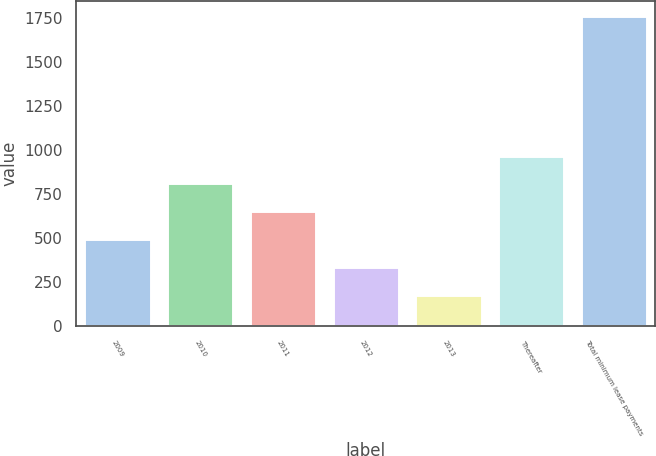Convert chart. <chart><loc_0><loc_0><loc_500><loc_500><bar_chart><fcel>2009<fcel>2010<fcel>2011<fcel>2012<fcel>2013<fcel>Thereafter<fcel>Total minimum lease payments<nl><fcel>493.6<fcel>810.2<fcel>651.9<fcel>335.3<fcel>177<fcel>968.5<fcel>1760<nl></chart> 